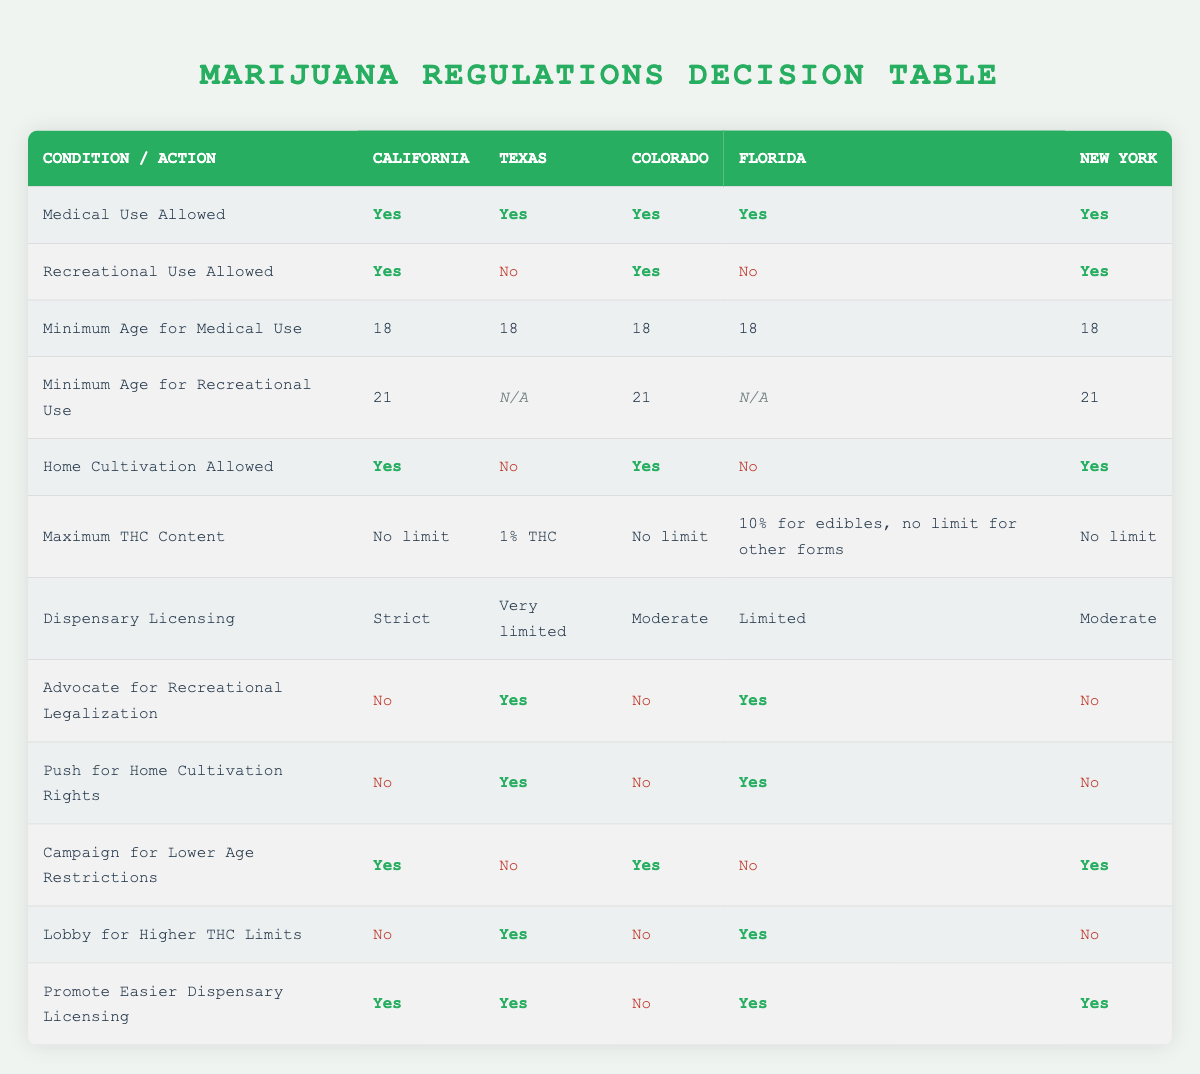What states allow both medical and recreational marijuana use? To find the states that allow both types of marijuana use, we look at the column for Recreational Use Allowed, which shows "Yes" for California, Colorado, and New York. Therefore, these three states permit both medical and recreational use.
Answer: California, Colorado, New York Which state has the most restrictive dispensary licensing? The table shows that Texas has "Very limited" dispensary licensing, which is more restrictive compared to California (Strict), Colorado (Moderate), Florida (Limited), and New York (Moderate). Thus, Texas has the most limitations.
Answer: Texas How many states allow home cultivation of marijuana? By checking the "Home Cultivation Allowed" row, we see that California, Colorado, and New York allow home cultivation (Yes), while Texas and Florida do not. Counting the "Yes" responses, we find that three states allow home cultivation.
Answer: 3 What is the maximum THC content allowed in Florida? In the table, Florida is noted to have "10% for edibles, no limit for other forms" under Maximum THC Content. This indicates that edibles have a specific limit, but other forms have no restrictions.
Answer: 10% for edibles, no limit for other forms Are there any states that advocate for recreational legalization despite not allowing recreational use? Looking at the "Advocate for Recreational Legalization" row, we see that Texas and Florida advocate for recreational legalization (Yes) while also having it restricted (Texas: No, Florida: No). Therefore, both states advocate for recreational legalization despite the limitations in their current laws.
Answer: Yes 